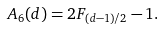Convert formula to latex. <formula><loc_0><loc_0><loc_500><loc_500>A _ { 6 } ( d ) = 2 F _ { ( d - 1 ) / 2 } - 1 .</formula> 